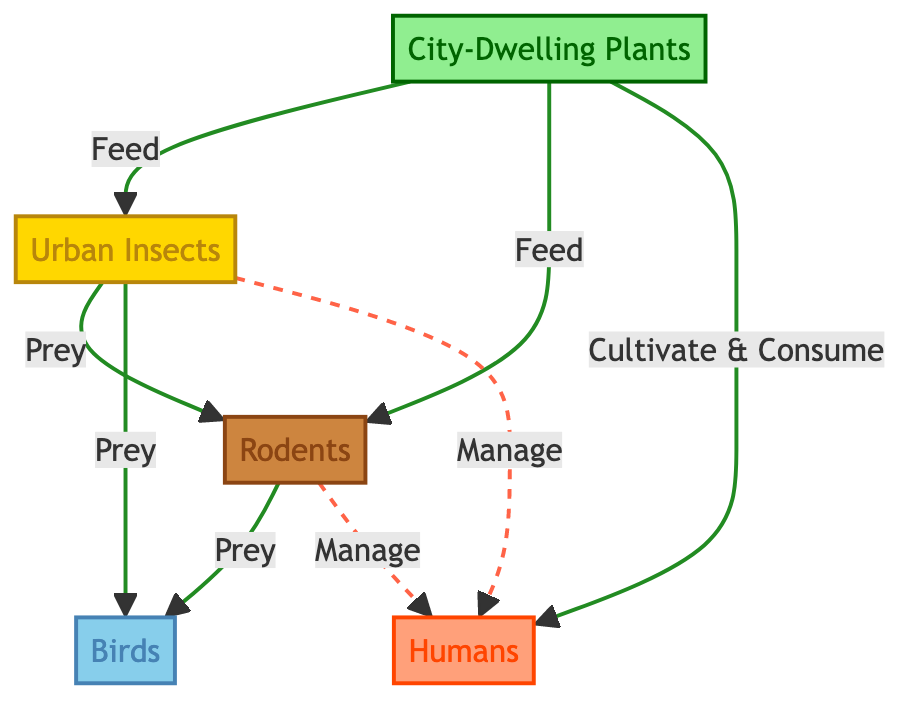What is the first node in the food chain? The first node in the food chain is indicated by the top position in the diagram. It is labeled "City-Dwelling Plants."
Answer: City-Dwelling Plants How many nodes are present in the diagram? To determine the number of nodes, we count all the unique boxes in the diagram. There are five distinct nodes: City-Dwelling Plants, Urban Insects, Rodents, Birds, and Humans.
Answer: 5 What type of relationship exists between Urban Insects and Rodents? The relationship between Urban Insects and Rodents can be identified by following the directed arrow from Urban Insects to Rodents, indicating that Urban Insects are preyed upon by Rodents.
Answer: Prey Which node is managed by both Rodents and Urban Insects? To answer this, we look for the node that has both Rodents and Urban Insects pointing towards it with a dashed line, indicating management. This node is Humans.
Answer: Humans What do City-Dwelling Plants provide to Rodents? By examining the arrows indicating the flow of energy or resources, we find that City-Dwelling Plants feed Rodents.
Answer: Feed What is the relationship between Humans and City-Dwelling Plants? The diagram shows a solid arrow from City-Dwelling Plants to Humans, signifying that Humans cultivate and consume these plants.
Answer: Cultivate & Consume How many prey relationships are represented in the diagram? We identify the arrows that point from one organism to another indicating predation: Urban Insects to Rodents, Rodents to Birds, and Urban Insects to Birds. This totals to three prey relationships.
Answer: 3 What does the dashed line from Rodents to Humans signify? The use of a dashed line indicates a different relationship compared to solid arrows. This line signifies that Rodents manage Humans, indicating a mutual influence without direct feeding.
Answer: Manage Which node is at the top of the food chain structure? The node at the top of the food chain structure, which is likely to be seen as the apex consumer or the one influenced the most, is determined by the flow of arrows. In this case, it’s Birds as they are at the third position down the flow.
Answer: Birds 